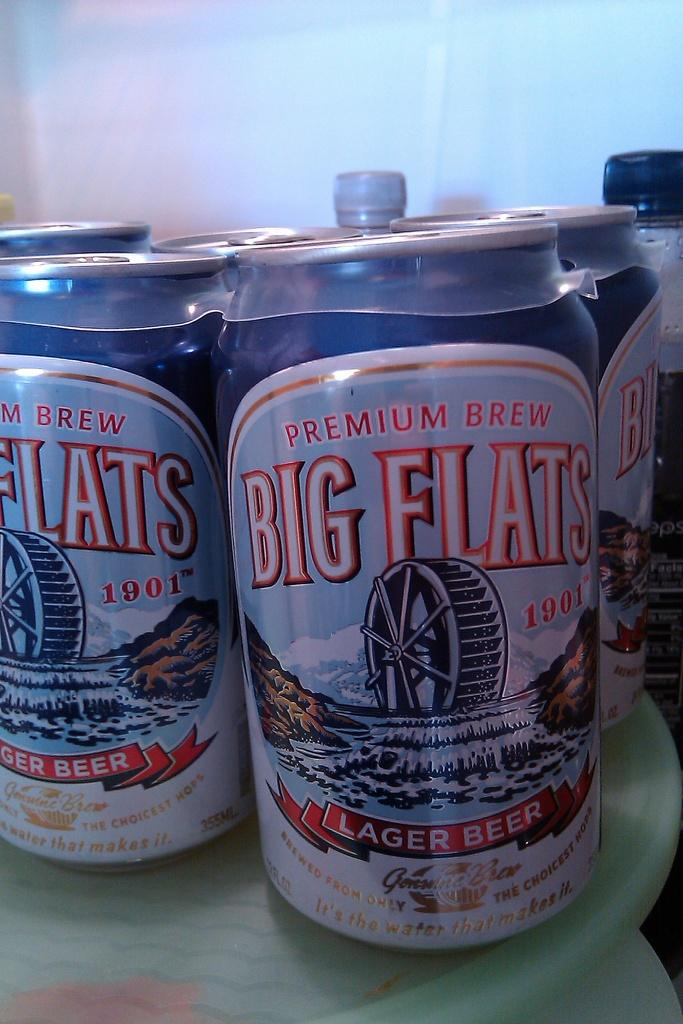<image>
Share a concise interpretation of the image provided. A pack of Big Flats lager beer sits in a fridge. 